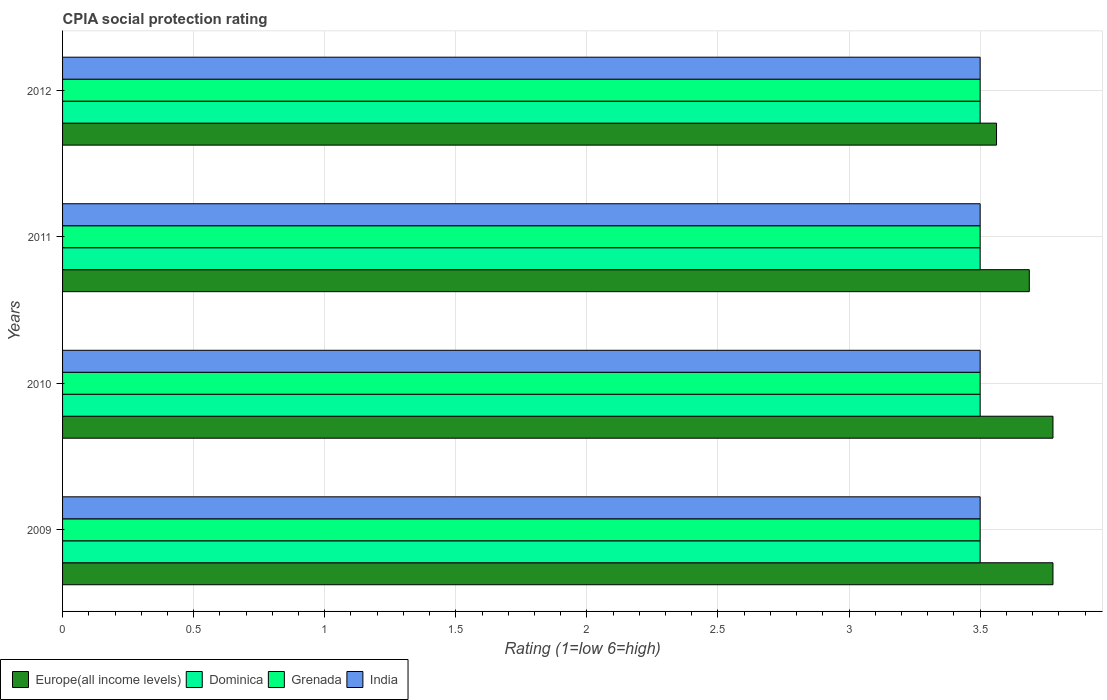Are the number of bars per tick equal to the number of legend labels?
Your answer should be very brief. Yes. How many bars are there on the 1st tick from the bottom?
Offer a very short reply. 4. In how many cases, is the number of bars for a given year not equal to the number of legend labels?
Your answer should be compact. 0. Across all years, what is the maximum CPIA rating in Dominica?
Ensure brevity in your answer.  3.5. In which year was the CPIA rating in Dominica maximum?
Provide a succinct answer. 2009. What is the total CPIA rating in India in the graph?
Provide a short and direct response. 14. What is the difference between the CPIA rating in Europe(all income levels) in 2011 and that in 2012?
Provide a succinct answer. 0.12. What is the difference between the CPIA rating in Europe(all income levels) in 2009 and the CPIA rating in Grenada in 2012?
Provide a succinct answer. 0.28. What is the average CPIA rating in Grenada per year?
Ensure brevity in your answer.  3.5. In how many years, is the CPIA rating in Dominica greater than 3.1 ?
Give a very brief answer. 4. What is the difference between the highest and the second highest CPIA rating in Europe(all income levels)?
Keep it short and to the point. 0. In how many years, is the CPIA rating in Grenada greater than the average CPIA rating in Grenada taken over all years?
Your answer should be compact. 0. Is it the case that in every year, the sum of the CPIA rating in India and CPIA rating in Europe(all income levels) is greater than the sum of CPIA rating in Dominica and CPIA rating in Grenada?
Your answer should be very brief. Yes. What does the 2nd bar from the top in 2009 represents?
Your response must be concise. Grenada. What does the 3rd bar from the bottom in 2010 represents?
Give a very brief answer. Grenada. Is it the case that in every year, the sum of the CPIA rating in Dominica and CPIA rating in Europe(all income levels) is greater than the CPIA rating in Grenada?
Offer a terse response. Yes. How many years are there in the graph?
Your response must be concise. 4. What is the difference between two consecutive major ticks on the X-axis?
Keep it short and to the point. 0.5. Are the values on the major ticks of X-axis written in scientific E-notation?
Offer a very short reply. No. Does the graph contain grids?
Provide a succinct answer. Yes. How are the legend labels stacked?
Give a very brief answer. Horizontal. What is the title of the graph?
Ensure brevity in your answer.  CPIA social protection rating. Does "Bahamas" appear as one of the legend labels in the graph?
Keep it short and to the point. No. What is the Rating (1=low 6=high) in Europe(all income levels) in 2009?
Make the answer very short. 3.78. What is the Rating (1=low 6=high) in Dominica in 2009?
Provide a succinct answer. 3.5. What is the Rating (1=low 6=high) of Grenada in 2009?
Your answer should be compact. 3.5. What is the Rating (1=low 6=high) of Europe(all income levels) in 2010?
Keep it short and to the point. 3.78. What is the Rating (1=low 6=high) in Dominica in 2010?
Provide a short and direct response. 3.5. What is the Rating (1=low 6=high) in Europe(all income levels) in 2011?
Offer a very short reply. 3.69. What is the Rating (1=low 6=high) of Dominica in 2011?
Ensure brevity in your answer.  3.5. What is the Rating (1=low 6=high) in Grenada in 2011?
Your answer should be compact. 3.5. What is the Rating (1=low 6=high) of India in 2011?
Your answer should be compact. 3.5. What is the Rating (1=low 6=high) of Europe(all income levels) in 2012?
Your response must be concise. 3.56. What is the Rating (1=low 6=high) of Grenada in 2012?
Your response must be concise. 3.5. What is the Rating (1=low 6=high) of India in 2012?
Your answer should be very brief. 3.5. Across all years, what is the maximum Rating (1=low 6=high) in Europe(all income levels)?
Your answer should be very brief. 3.78. Across all years, what is the maximum Rating (1=low 6=high) of Dominica?
Provide a short and direct response. 3.5. Across all years, what is the maximum Rating (1=low 6=high) of Grenada?
Give a very brief answer. 3.5. Across all years, what is the minimum Rating (1=low 6=high) in Europe(all income levels)?
Offer a very short reply. 3.56. What is the total Rating (1=low 6=high) in Europe(all income levels) in the graph?
Your answer should be compact. 14.81. What is the total Rating (1=low 6=high) in Dominica in the graph?
Your response must be concise. 14. What is the total Rating (1=low 6=high) in Grenada in the graph?
Give a very brief answer. 14. What is the total Rating (1=low 6=high) in India in the graph?
Provide a short and direct response. 14. What is the difference between the Rating (1=low 6=high) in Europe(all income levels) in 2009 and that in 2010?
Give a very brief answer. 0. What is the difference between the Rating (1=low 6=high) of Dominica in 2009 and that in 2010?
Provide a short and direct response. 0. What is the difference between the Rating (1=low 6=high) in Europe(all income levels) in 2009 and that in 2011?
Make the answer very short. 0.09. What is the difference between the Rating (1=low 6=high) in Dominica in 2009 and that in 2011?
Your response must be concise. 0. What is the difference between the Rating (1=low 6=high) in India in 2009 and that in 2011?
Offer a terse response. 0. What is the difference between the Rating (1=low 6=high) in Europe(all income levels) in 2009 and that in 2012?
Your answer should be very brief. 0.22. What is the difference between the Rating (1=low 6=high) in Dominica in 2009 and that in 2012?
Offer a terse response. 0. What is the difference between the Rating (1=low 6=high) of India in 2009 and that in 2012?
Give a very brief answer. 0. What is the difference between the Rating (1=low 6=high) of Europe(all income levels) in 2010 and that in 2011?
Offer a very short reply. 0.09. What is the difference between the Rating (1=low 6=high) of Grenada in 2010 and that in 2011?
Ensure brevity in your answer.  0. What is the difference between the Rating (1=low 6=high) of Europe(all income levels) in 2010 and that in 2012?
Offer a very short reply. 0.22. What is the difference between the Rating (1=low 6=high) in Dominica in 2010 and that in 2012?
Keep it short and to the point. 0. What is the difference between the Rating (1=low 6=high) of Dominica in 2011 and that in 2012?
Your answer should be compact. 0. What is the difference between the Rating (1=low 6=high) of Europe(all income levels) in 2009 and the Rating (1=low 6=high) of Dominica in 2010?
Offer a terse response. 0.28. What is the difference between the Rating (1=low 6=high) in Europe(all income levels) in 2009 and the Rating (1=low 6=high) in Grenada in 2010?
Your answer should be very brief. 0.28. What is the difference between the Rating (1=low 6=high) in Europe(all income levels) in 2009 and the Rating (1=low 6=high) in India in 2010?
Your answer should be compact. 0.28. What is the difference between the Rating (1=low 6=high) of Dominica in 2009 and the Rating (1=low 6=high) of Grenada in 2010?
Offer a very short reply. 0. What is the difference between the Rating (1=low 6=high) in Dominica in 2009 and the Rating (1=low 6=high) in India in 2010?
Ensure brevity in your answer.  0. What is the difference between the Rating (1=low 6=high) in Grenada in 2009 and the Rating (1=low 6=high) in India in 2010?
Make the answer very short. 0. What is the difference between the Rating (1=low 6=high) in Europe(all income levels) in 2009 and the Rating (1=low 6=high) in Dominica in 2011?
Keep it short and to the point. 0.28. What is the difference between the Rating (1=low 6=high) of Europe(all income levels) in 2009 and the Rating (1=low 6=high) of Grenada in 2011?
Provide a succinct answer. 0.28. What is the difference between the Rating (1=low 6=high) of Europe(all income levels) in 2009 and the Rating (1=low 6=high) of India in 2011?
Your response must be concise. 0.28. What is the difference between the Rating (1=low 6=high) of Dominica in 2009 and the Rating (1=low 6=high) of Grenada in 2011?
Provide a succinct answer. 0. What is the difference between the Rating (1=low 6=high) in Dominica in 2009 and the Rating (1=low 6=high) in India in 2011?
Your answer should be compact. 0. What is the difference between the Rating (1=low 6=high) in Grenada in 2009 and the Rating (1=low 6=high) in India in 2011?
Offer a terse response. 0. What is the difference between the Rating (1=low 6=high) of Europe(all income levels) in 2009 and the Rating (1=low 6=high) of Dominica in 2012?
Offer a very short reply. 0.28. What is the difference between the Rating (1=low 6=high) in Europe(all income levels) in 2009 and the Rating (1=low 6=high) in Grenada in 2012?
Provide a short and direct response. 0.28. What is the difference between the Rating (1=low 6=high) in Europe(all income levels) in 2009 and the Rating (1=low 6=high) in India in 2012?
Provide a short and direct response. 0.28. What is the difference between the Rating (1=low 6=high) of Dominica in 2009 and the Rating (1=low 6=high) of Grenada in 2012?
Provide a short and direct response. 0. What is the difference between the Rating (1=low 6=high) in Dominica in 2009 and the Rating (1=low 6=high) in India in 2012?
Offer a very short reply. 0. What is the difference between the Rating (1=low 6=high) in Grenada in 2009 and the Rating (1=low 6=high) in India in 2012?
Your answer should be very brief. 0. What is the difference between the Rating (1=low 6=high) in Europe(all income levels) in 2010 and the Rating (1=low 6=high) in Dominica in 2011?
Offer a terse response. 0.28. What is the difference between the Rating (1=low 6=high) in Europe(all income levels) in 2010 and the Rating (1=low 6=high) in Grenada in 2011?
Provide a succinct answer. 0.28. What is the difference between the Rating (1=low 6=high) of Europe(all income levels) in 2010 and the Rating (1=low 6=high) of India in 2011?
Offer a very short reply. 0.28. What is the difference between the Rating (1=low 6=high) in Dominica in 2010 and the Rating (1=low 6=high) in Grenada in 2011?
Ensure brevity in your answer.  0. What is the difference between the Rating (1=low 6=high) of Dominica in 2010 and the Rating (1=low 6=high) of India in 2011?
Your answer should be compact. 0. What is the difference between the Rating (1=low 6=high) in Europe(all income levels) in 2010 and the Rating (1=low 6=high) in Dominica in 2012?
Offer a very short reply. 0.28. What is the difference between the Rating (1=low 6=high) in Europe(all income levels) in 2010 and the Rating (1=low 6=high) in Grenada in 2012?
Your answer should be compact. 0.28. What is the difference between the Rating (1=low 6=high) in Europe(all income levels) in 2010 and the Rating (1=low 6=high) in India in 2012?
Your response must be concise. 0.28. What is the difference between the Rating (1=low 6=high) in Dominica in 2010 and the Rating (1=low 6=high) in Grenada in 2012?
Your answer should be very brief. 0. What is the difference between the Rating (1=low 6=high) in Dominica in 2010 and the Rating (1=low 6=high) in India in 2012?
Your response must be concise. 0. What is the difference between the Rating (1=low 6=high) of Grenada in 2010 and the Rating (1=low 6=high) of India in 2012?
Your answer should be very brief. 0. What is the difference between the Rating (1=low 6=high) of Europe(all income levels) in 2011 and the Rating (1=low 6=high) of Dominica in 2012?
Give a very brief answer. 0.19. What is the difference between the Rating (1=low 6=high) in Europe(all income levels) in 2011 and the Rating (1=low 6=high) in Grenada in 2012?
Keep it short and to the point. 0.19. What is the difference between the Rating (1=low 6=high) in Europe(all income levels) in 2011 and the Rating (1=low 6=high) in India in 2012?
Ensure brevity in your answer.  0.19. What is the difference between the Rating (1=low 6=high) of Dominica in 2011 and the Rating (1=low 6=high) of Grenada in 2012?
Ensure brevity in your answer.  0. What is the average Rating (1=low 6=high) of Europe(all income levels) per year?
Your response must be concise. 3.7. What is the average Rating (1=low 6=high) of Grenada per year?
Provide a succinct answer. 3.5. In the year 2009, what is the difference between the Rating (1=low 6=high) of Europe(all income levels) and Rating (1=low 6=high) of Dominica?
Offer a very short reply. 0.28. In the year 2009, what is the difference between the Rating (1=low 6=high) of Europe(all income levels) and Rating (1=low 6=high) of Grenada?
Ensure brevity in your answer.  0.28. In the year 2009, what is the difference between the Rating (1=low 6=high) in Europe(all income levels) and Rating (1=low 6=high) in India?
Keep it short and to the point. 0.28. In the year 2009, what is the difference between the Rating (1=low 6=high) of Dominica and Rating (1=low 6=high) of Grenada?
Give a very brief answer. 0. In the year 2010, what is the difference between the Rating (1=low 6=high) in Europe(all income levels) and Rating (1=low 6=high) in Dominica?
Make the answer very short. 0.28. In the year 2010, what is the difference between the Rating (1=low 6=high) of Europe(all income levels) and Rating (1=low 6=high) of Grenada?
Offer a very short reply. 0.28. In the year 2010, what is the difference between the Rating (1=low 6=high) of Europe(all income levels) and Rating (1=low 6=high) of India?
Your response must be concise. 0.28. In the year 2010, what is the difference between the Rating (1=low 6=high) in Dominica and Rating (1=low 6=high) in Grenada?
Your answer should be very brief. 0. In the year 2010, what is the difference between the Rating (1=low 6=high) of Grenada and Rating (1=low 6=high) of India?
Ensure brevity in your answer.  0. In the year 2011, what is the difference between the Rating (1=low 6=high) in Europe(all income levels) and Rating (1=low 6=high) in Dominica?
Make the answer very short. 0.19. In the year 2011, what is the difference between the Rating (1=low 6=high) of Europe(all income levels) and Rating (1=low 6=high) of Grenada?
Make the answer very short. 0.19. In the year 2011, what is the difference between the Rating (1=low 6=high) in Europe(all income levels) and Rating (1=low 6=high) in India?
Your answer should be very brief. 0.19. In the year 2011, what is the difference between the Rating (1=low 6=high) in Dominica and Rating (1=low 6=high) in Grenada?
Keep it short and to the point. 0. In the year 2011, what is the difference between the Rating (1=low 6=high) in Dominica and Rating (1=low 6=high) in India?
Provide a short and direct response. 0. In the year 2011, what is the difference between the Rating (1=low 6=high) in Grenada and Rating (1=low 6=high) in India?
Ensure brevity in your answer.  0. In the year 2012, what is the difference between the Rating (1=low 6=high) of Europe(all income levels) and Rating (1=low 6=high) of Dominica?
Make the answer very short. 0.06. In the year 2012, what is the difference between the Rating (1=low 6=high) in Europe(all income levels) and Rating (1=low 6=high) in Grenada?
Keep it short and to the point. 0.06. In the year 2012, what is the difference between the Rating (1=low 6=high) of Europe(all income levels) and Rating (1=low 6=high) of India?
Offer a terse response. 0.06. In the year 2012, what is the difference between the Rating (1=low 6=high) of Dominica and Rating (1=low 6=high) of Grenada?
Provide a succinct answer. 0. In the year 2012, what is the difference between the Rating (1=low 6=high) in Grenada and Rating (1=low 6=high) in India?
Ensure brevity in your answer.  0. What is the ratio of the Rating (1=low 6=high) in Grenada in 2009 to that in 2010?
Ensure brevity in your answer.  1. What is the ratio of the Rating (1=low 6=high) of India in 2009 to that in 2010?
Offer a very short reply. 1. What is the ratio of the Rating (1=low 6=high) of Europe(all income levels) in 2009 to that in 2011?
Offer a terse response. 1.02. What is the ratio of the Rating (1=low 6=high) in Dominica in 2009 to that in 2011?
Offer a terse response. 1. What is the ratio of the Rating (1=low 6=high) of India in 2009 to that in 2011?
Your answer should be very brief. 1. What is the ratio of the Rating (1=low 6=high) in Europe(all income levels) in 2009 to that in 2012?
Offer a terse response. 1.06. What is the ratio of the Rating (1=low 6=high) of Grenada in 2009 to that in 2012?
Offer a terse response. 1. What is the ratio of the Rating (1=low 6=high) of Europe(all income levels) in 2010 to that in 2011?
Offer a very short reply. 1.02. What is the ratio of the Rating (1=low 6=high) of Dominica in 2010 to that in 2011?
Keep it short and to the point. 1. What is the ratio of the Rating (1=low 6=high) of India in 2010 to that in 2011?
Your response must be concise. 1. What is the ratio of the Rating (1=low 6=high) in Europe(all income levels) in 2010 to that in 2012?
Your answer should be compact. 1.06. What is the ratio of the Rating (1=low 6=high) of Grenada in 2010 to that in 2012?
Provide a short and direct response. 1. What is the ratio of the Rating (1=low 6=high) of Europe(all income levels) in 2011 to that in 2012?
Offer a very short reply. 1.04. What is the ratio of the Rating (1=low 6=high) in Dominica in 2011 to that in 2012?
Offer a very short reply. 1. What is the ratio of the Rating (1=low 6=high) in Grenada in 2011 to that in 2012?
Your answer should be compact. 1. What is the difference between the highest and the second highest Rating (1=low 6=high) in Europe(all income levels)?
Provide a succinct answer. 0. What is the difference between the highest and the second highest Rating (1=low 6=high) of Dominica?
Your response must be concise. 0. What is the difference between the highest and the second highest Rating (1=low 6=high) in Grenada?
Your answer should be compact. 0. What is the difference between the highest and the lowest Rating (1=low 6=high) of Europe(all income levels)?
Provide a succinct answer. 0.22. What is the difference between the highest and the lowest Rating (1=low 6=high) of India?
Your answer should be very brief. 0. 